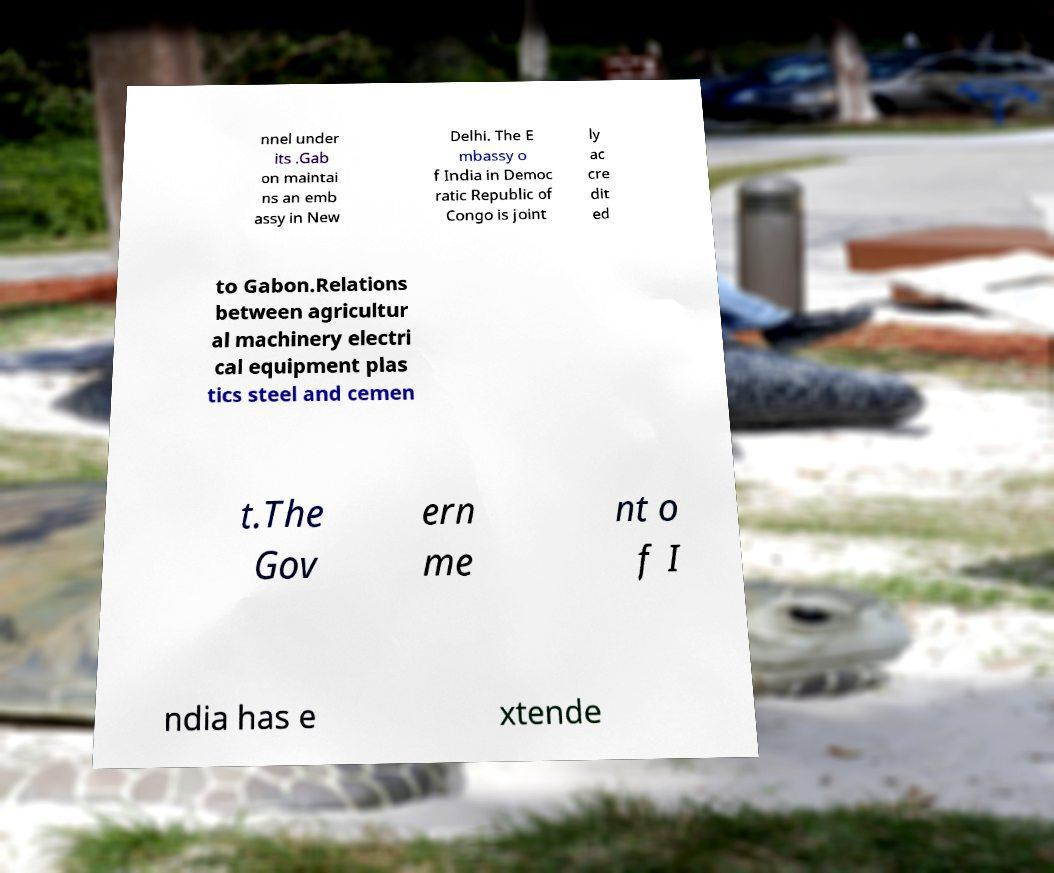Could you extract and type out the text from this image? nnel under its .Gab on maintai ns an emb assy in New Delhi. The E mbassy o f India in Democ ratic Republic of Congo is joint ly ac cre dit ed to Gabon.Relations between agricultur al machinery electri cal equipment plas tics steel and cemen t.The Gov ern me nt o f I ndia has e xtende 